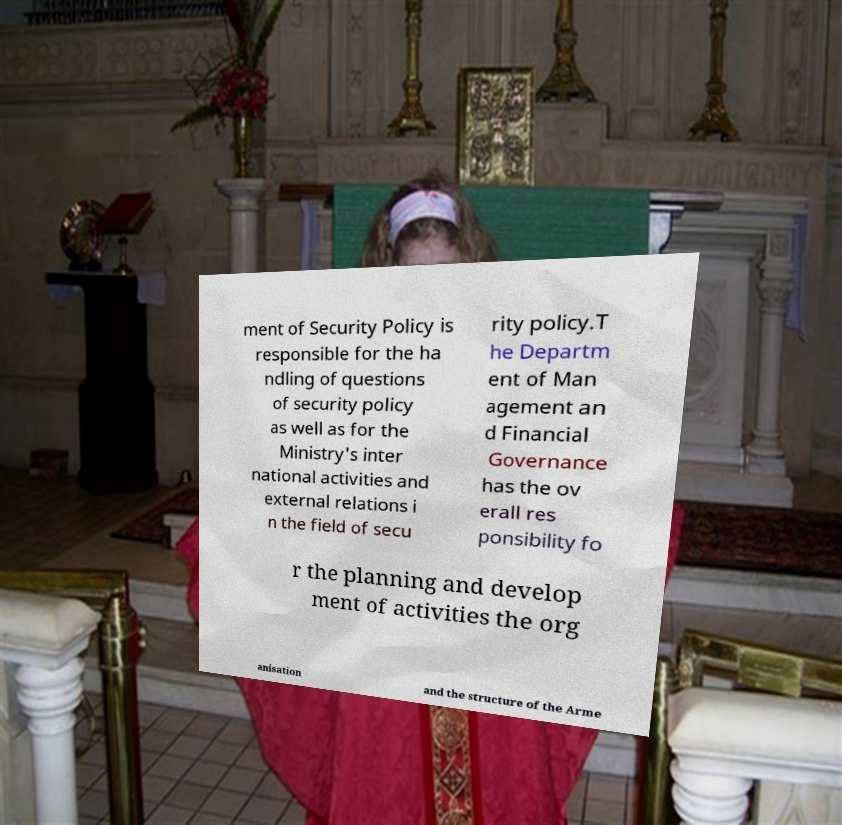I need the written content from this picture converted into text. Can you do that? ment of Security Policy is responsible for the ha ndling of questions of security policy as well as for the Ministry's inter national activities and external relations i n the field of secu rity policy.T he Departm ent of Man agement an d Financial Governance has the ov erall res ponsibility fo r the planning and develop ment of activities the org anisation and the structure of the Arme 